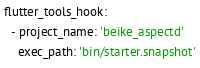Convert code to text. <code><loc_0><loc_0><loc_500><loc_500><_YAML_>flutter_tools_hook:
  - project_name: 'beike_aspectd'
    exec_path: 'bin/starter.snapshot'</code> 